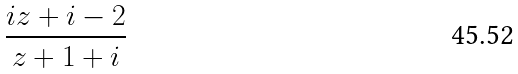Convert formula to latex. <formula><loc_0><loc_0><loc_500><loc_500>\frac { i z + i - 2 } { z + 1 + i }</formula> 